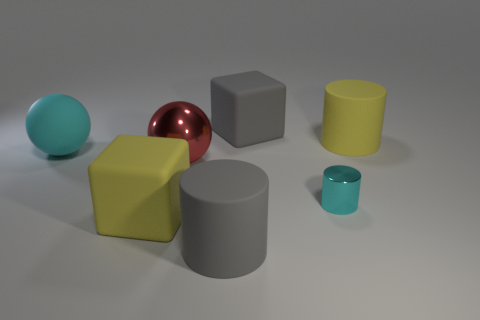Are there the same number of rubber blocks that are in front of the large gray block and metallic spheres in front of the big red shiny sphere? Upon reviewing the image, the number of rubber blocks in front of the large gray block does not match the number of metallic spheres in front of the large red shiny sphere. To provide more clarity, the number of rubber blocks and metallic spheres should be counted and compared directly. 